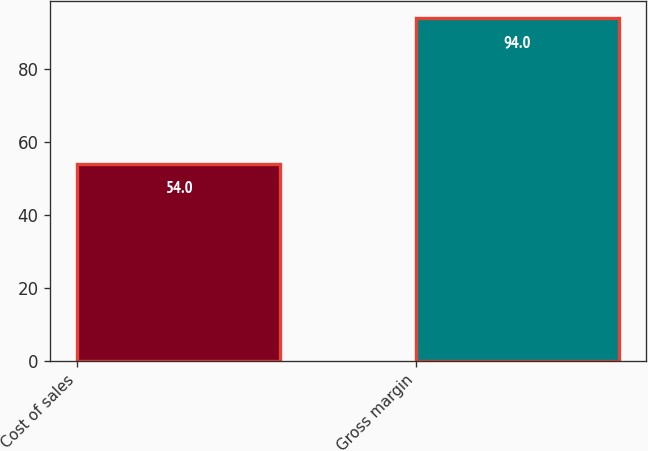Convert chart. <chart><loc_0><loc_0><loc_500><loc_500><bar_chart><fcel>Cost of sales<fcel>Gross margin<nl><fcel>54<fcel>94<nl></chart> 